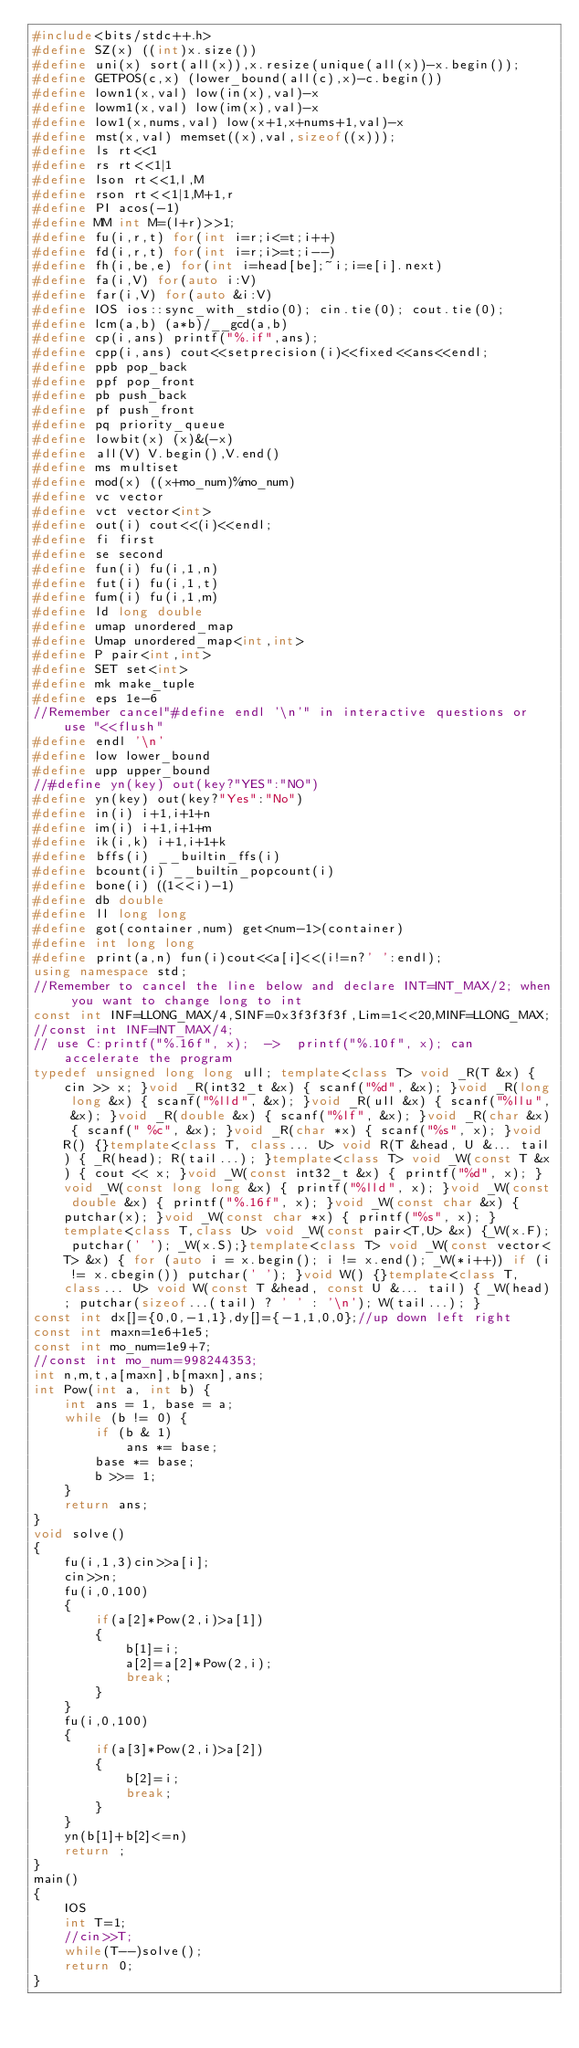Convert code to text. <code><loc_0><loc_0><loc_500><loc_500><_C++_>#include<bits/stdc++.h>
#define SZ(x) ((int)x.size())
#define uni(x) sort(all(x)),x.resize(unique(all(x))-x.begin());
#define GETPOS(c,x) (lower_bound(all(c),x)-c.begin())
#define lown1(x,val) low(in(x),val)-x
#define lowm1(x,val) low(im(x),val)-x
#define low1(x,nums,val) low(x+1,x+nums+1,val)-x
#define mst(x,val) memset((x),val,sizeof((x)));
#define ls rt<<1
#define rs rt<<1|1
#define lson rt<<1,l,M
#define rson rt<<1|1,M+1,r
#define PI acos(-1)
#define MM int M=(l+r)>>1;
#define fu(i,r,t) for(int i=r;i<=t;i++)
#define fd(i,r,t) for(int i=r;i>=t;i--)
#define fh(i,be,e) for(int i=head[be];~i;i=e[i].next)
#define fa(i,V) for(auto i:V)
#define far(i,V) for(auto &i:V)
#define IOS ios::sync_with_stdio(0); cin.tie(0); cout.tie(0);
#define lcm(a,b) (a*b)/__gcd(a,b)
#define cp(i,ans) printf("%.if",ans);
#define cpp(i,ans) cout<<setprecision(i)<<fixed<<ans<<endl;
#define ppb pop_back
#define ppf pop_front
#define pb push_back
#define pf push_front
#define pq priority_queue
#define lowbit(x) (x)&(-x)
#define all(V) V.begin(),V.end()
#define ms multiset
#define mod(x) ((x+mo_num)%mo_num)
#define vc vector
#define vct vector<int>
#define out(i) cout<<(i)<<endl;
#define fi first
#define se second
#define fun(i) fu(i,1,n)
#define fut(i) fu(i,1,t)
#define fum(i) fu(i,1,m)
#define ld long double
#define umap unordered_map
#define Umap unordered_map<int,int>
#define P pair<int,int>
#define SET set<int>
#define mk make_tuple
#define eps 1e-6
//Remember cancel"#define endl '\n'" in interactive questions or use "<<flush"
#define endl '\n'
#define low lower_bound
#define upp upper_bound
//#define yn(key) out(key?"YES":"NO")
#define yn(key) out(key?"Yes":"No")
#define in(i) i+1,i+1+n
#define im(i) i+1,i+1+m
#define ik(i,k) i+1,i+1+k
#define bffs(i) __builtin_ffs(i)
#define bcount(i) __builtin_popcount(i)
#define bone(i) ((1<<i)-1)
#define db double
#define ll long long
#define got(container,num) get<num-1>(container)
#define int long long
#define print(a,n) fun(i)cout<<a[i]<<(i!=n?' ':endl);
using namespace std;
//Remember to cancel the line below and declare INT=INT_MAX/2; when you want to change long to int
const int INF=LLONG_MAX/4,SINF=0x3f3f3f3f,Lim=1<<20,MINF=LLONG_MAX;
//const int INF=INT_MAX/4;
// use C:printf("%.16f", x);  ->  printf("%.10f", x); can accelerate the program
typedef unsigned long long ull; template<class T> void _R(T &x) { cin >> x; }void _R(int32_t &x) { scanf("%d", &x); }void _R(long long &x) { scanf("%lld", &x); }void _R(ull &x) { scanf("%llu", &x); }void _R(double &x) { scanf("%lf", &x); }void _R(char &x) { scanf(" %c", &x); }void _R(char *x) { scanf("%s", x); }void R() {}template<class T, class... U> void R(T &head, U &... tail) { _R(head); R(tail...); }template<class T> void _W(const T &x) { cout << x; }void _W(const int32_t &x) { printf("%d", x); }void _W(const long long &x) { printf("%lld", x); }void _W(const double &x) { printf("%.16f", x); }void _W(const char &x) { putchar(x); }void _W(const char *x) { printf("%s", x); }template<class T,class U> void _W(const pair<T,U> &x) {_W(x.F); putchar(' '); _W(x.S);}template<class T> void _W(const vector<T> &x) { for (auto i = x.begin(); i != x.end(); _W(*i++)) if (i != x.cbegin()) putchar(' '); }void W() {}template<class T, class... U> void W(const T &head, const U &... tail) { _W(head); putchar(sizeof...(tail) ? ' ' : '\n'); W(tail...); }
const int dx[]={0,0,-1,1},dy[]={-1,1,0,0};//up down left right
const int maxn=1e6+1e5;
const int mo_num=1e9+7;
//const int mo_num=998244353;
int n,m,t,a[maxn],b[maxn],ans;
int Pow(int a, int b) {
    int ans = 1, base = a;
    while (b != 0) {
        if (b & 1)
            ans *= base;
        base *= base;
        b >>= 1;
    }
    return ans;
}
void solve()
{
    fu(i,1,3)cin>>a[i];
    cin>>n;
    fu(i,0,100)
    {
        if(a[2]*Pow(2,i)>a[1])
        {
            b[1]=i;
            a[2]=a[2]*Pow(2,i);
            break;
        }
    }
    fu(i,0,100)
    {
        if(a[3]*Pow(2,i)>a[2])
        {
            b[2]=i;
            break;
        }
    }
    yn(b[1]+b[2]<=n)
    return ;
}
main()
{
    IOS
    int T=1;
    //cin>>T;
    while(T--)solve();
    return 0;
}
</code> 